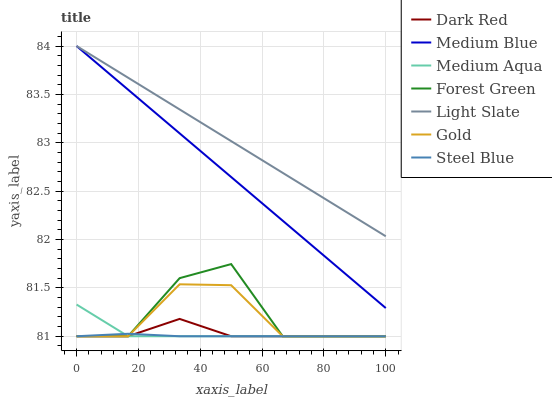Does Steel Blue have the minimum area under the curve?
Answer yes or no. Yes. Does Light Slate have the maximum area under the curve?
Answer yes or no. Yes. Does Dark Red have the minimum area under the curve?
Answer yes or no. No. Does Dark Red have the maximum area under the curve?
Answer yes or no. No. Is Light Slate the smoothest?
Answer yes or no. Yes. Is Forest Green the roughest?
Answer yes or no. Yes. Is Dark Red the smoothest?
Answer yes or no. No. Is Dark Red the roughest?
Answer yes or no. No. Does Gold have the lowest value?
Answer yes or no. Yes. Does Light Slate have the lowest value?
Answer yes or no. No. Does Medium Blue have the highest value?
Answer yes or no. Yes. Does Dark Red have the highest value?
Answer yes or no. No. Is Steel Blue less than Medium Blue?
Answer yes or no. Yes. Is Light Slate greater than Gold?
Answer yes or no. Yes. Does Dark Red intersect Steel Blue?
Answer yes or no. Yes. Is Dark Red less than Steel Blue?
Answer yes or no. No. Is Dark Red greater than Steel Blue?
Answer yes or no. No. Does Steel Blue intersect Medium Blue?
Answer yes or no. No. 